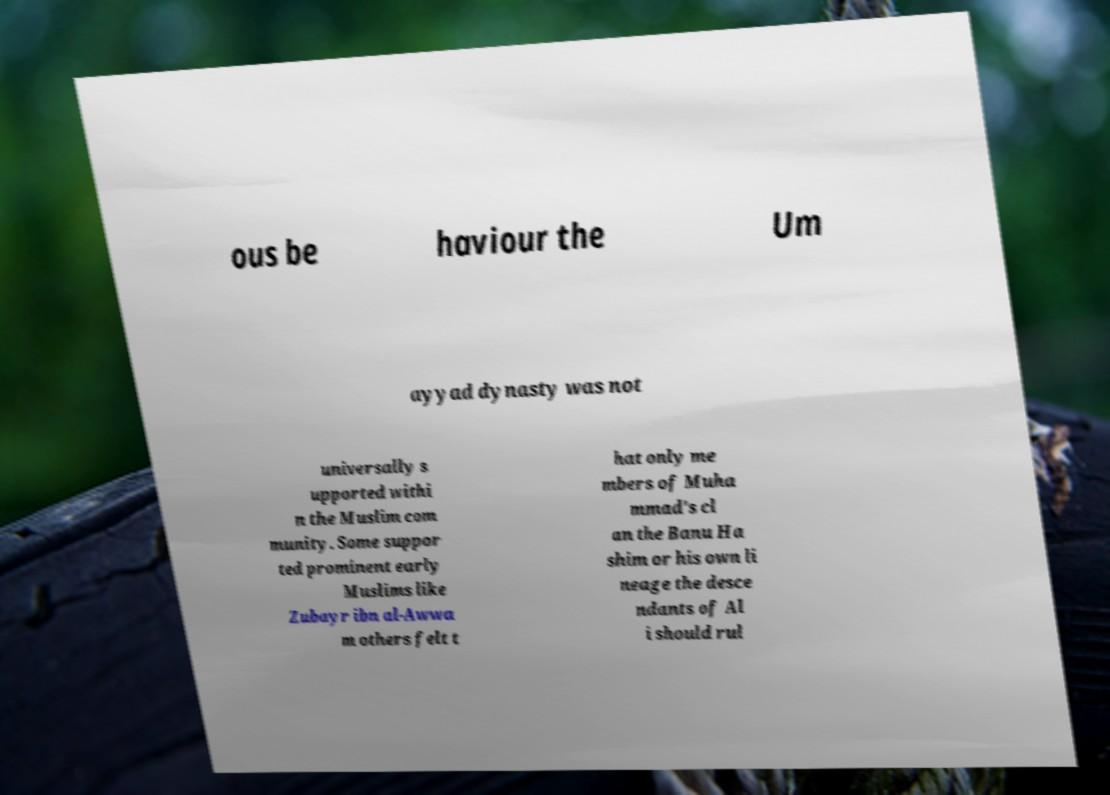I need the written content from this picture converted into text. Can you do that? ous be haviour the Um ayyad dynasty was not universally s upported withi n the Muslim com munity. Some suppor ted prominent early Muslims like Zubayr ibn al-Awwa m others felt t hat only me mbers of Muha mmad's cl an the Banu Ha shim or his own li neage the desce ndants of Al i should rul 